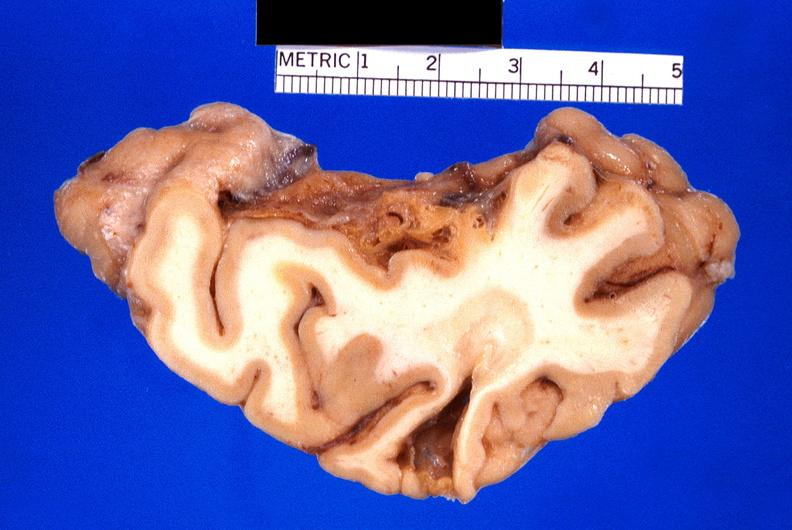does this image show brain, old infarcts, embolic?
Answer the question using a single word or phrase. Yes 